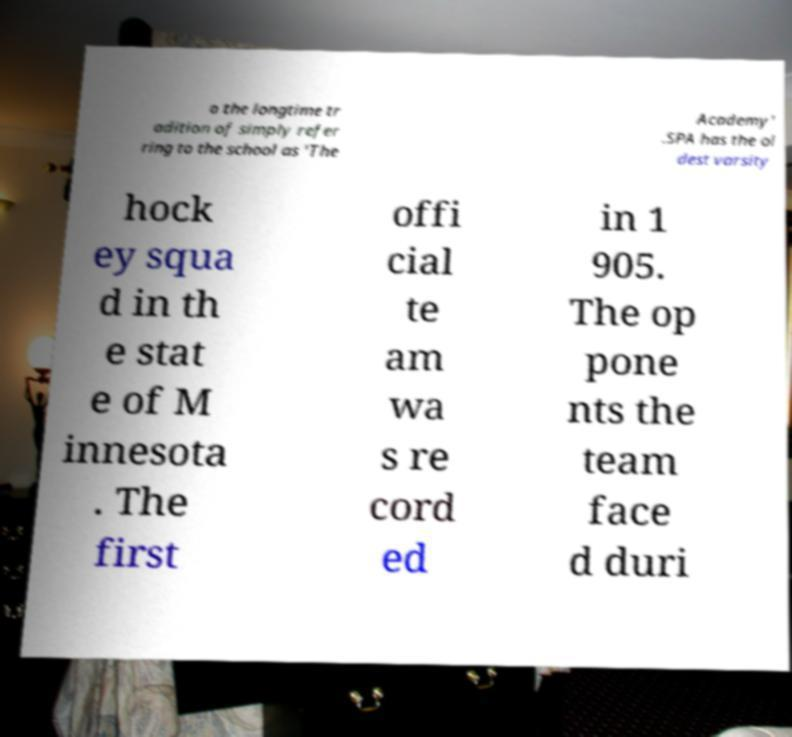Could you assist in decoding the text presented in this image and type it out clearly? o the longtime tr adition of simply refer ring to the school as 'The Academy' .SPA has the ol dest varsity hock ey squa d in th e stat e of M innesota . The first offi cial te am wa s re cord ed in 1 905. The op pone nts the team face d duri 